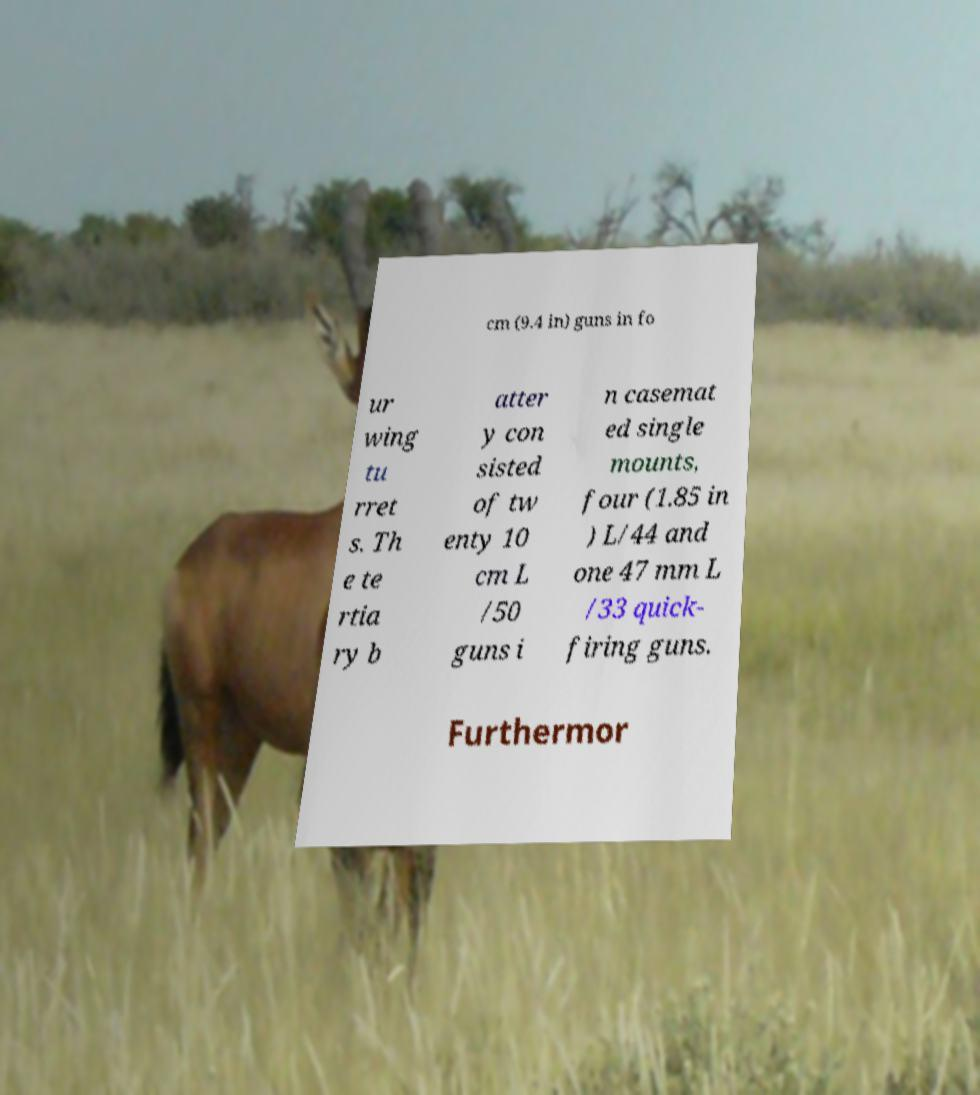Could you assist in decoding the text presented in this image and type it out clearly? cm (9.4 in) guns in fo ur wing tu rret s. Th e te rtia ry b atter y con sisted of tw enty 10 cm L /50 guns i n casemat ed single mounts, four (1.85 in ) L/44 and one 47 mm L /33 quick- firing guns. Furthermor 